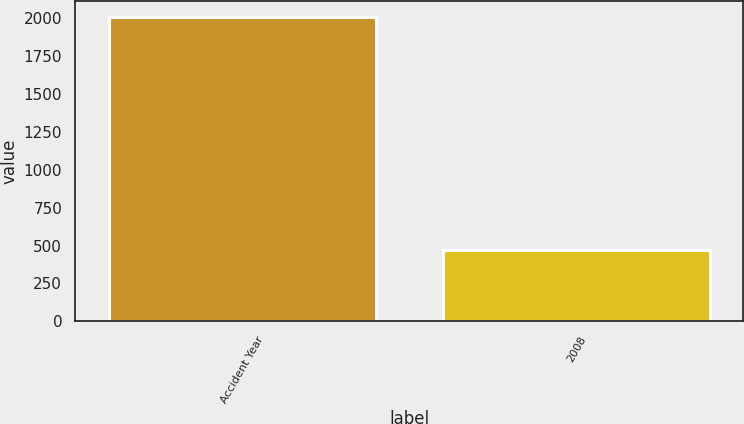Convert chart to OTSL. <chart><loc_0><loc_0><loc_500><loc_500><bar_chart><fcel>Accident Year<fcel>2008<nl><fcel>2008<fcel>469<nl></chart> 